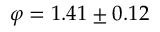<formula> <loc_0><loc_0><loc_500><loc_500>\varphi = 1 . 4 1 \pm 0 . 1 2</formula> 